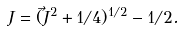<formula> <loc_0><loc_0><loc_500><loc_500>J = ( \vec { J } ^ { 2 } + 1 / 4 ) ^ { 1 / 2 } - 1 / 2 .</formula> 